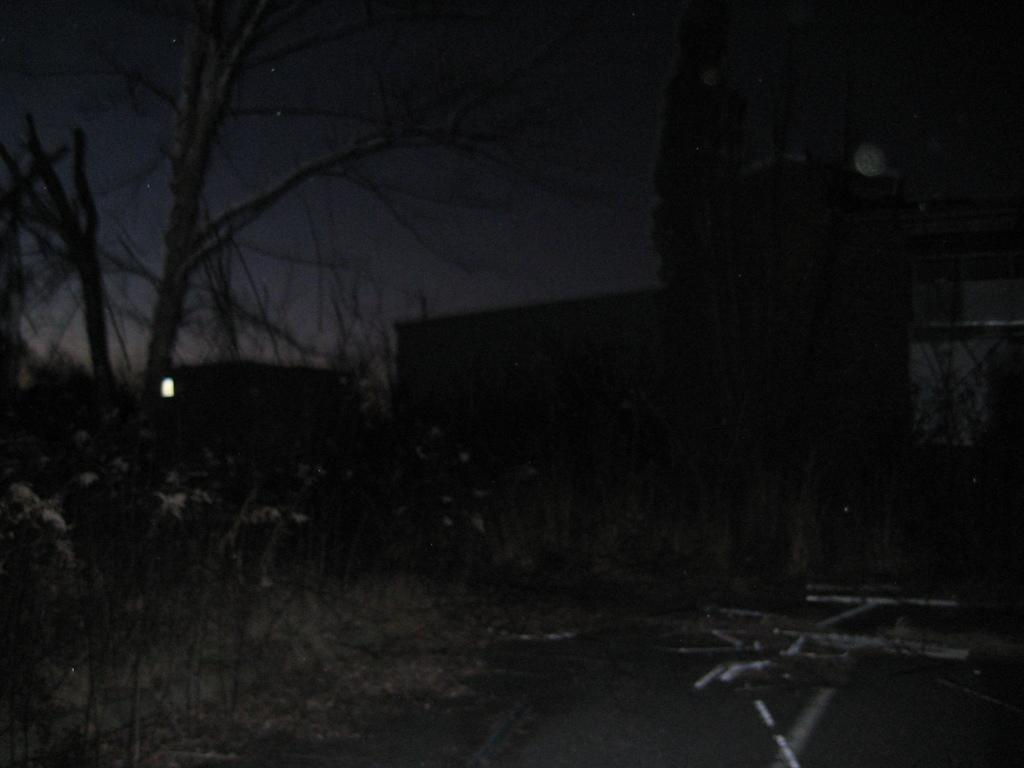What can be seen in the foreground of the image? There are plants and wooden or iron objects in the foreground of the image. What is located in the center of the image? There are trees and a building in the center of the image. What is the overall lighting condition in the image? The image appears to be dark. What type of fruit is hanging from the trees in the image? There is no fruit visible on the trees in the image. Can you hear someone coughing in the image? There is no sound present in the image, so it is impossible to determine if someone is coughing. 